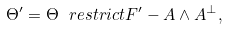<formula> <loc_0><loc_0><loc_500><loc_500>\Theta ^ { \prime } = \Theta \ r e s t r i c t { F ^ { \prime } } - A \wedge A ^ { \bot } ,</formula> 